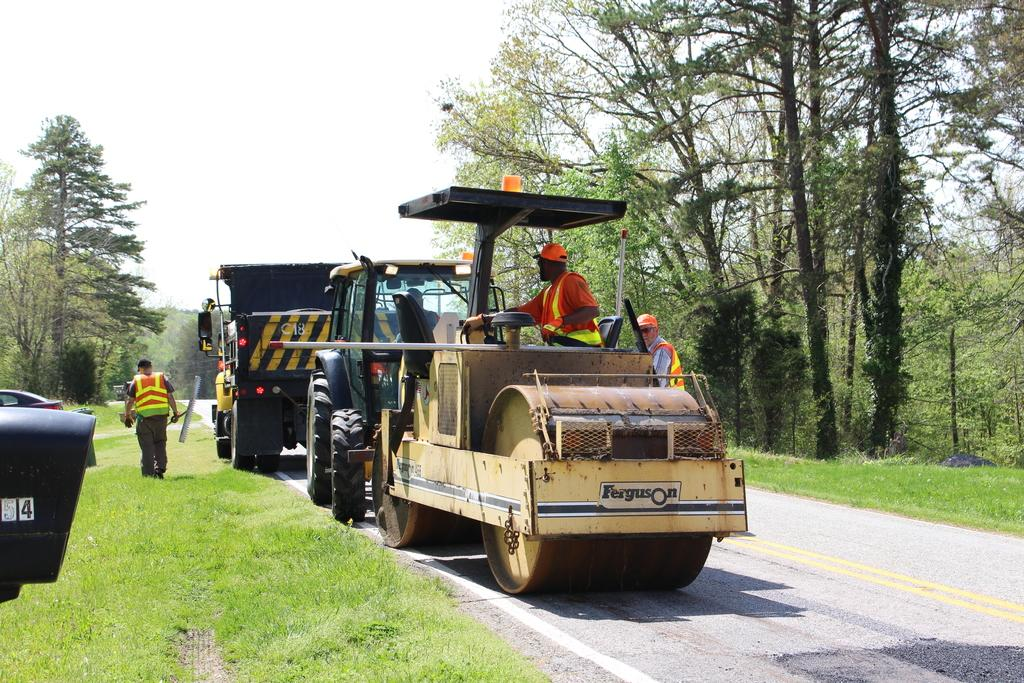What type of vehicle is present in the image? There is a road-roller and a truck in the image. What are the people in the image doing? There are people walking on the road in the image. What can be seen in the background of the image? There are trees and a clear sky in the background of the image. What type of butter is being used to grease the road in the image? There is no butter present in the image, and the road is not being greased. 